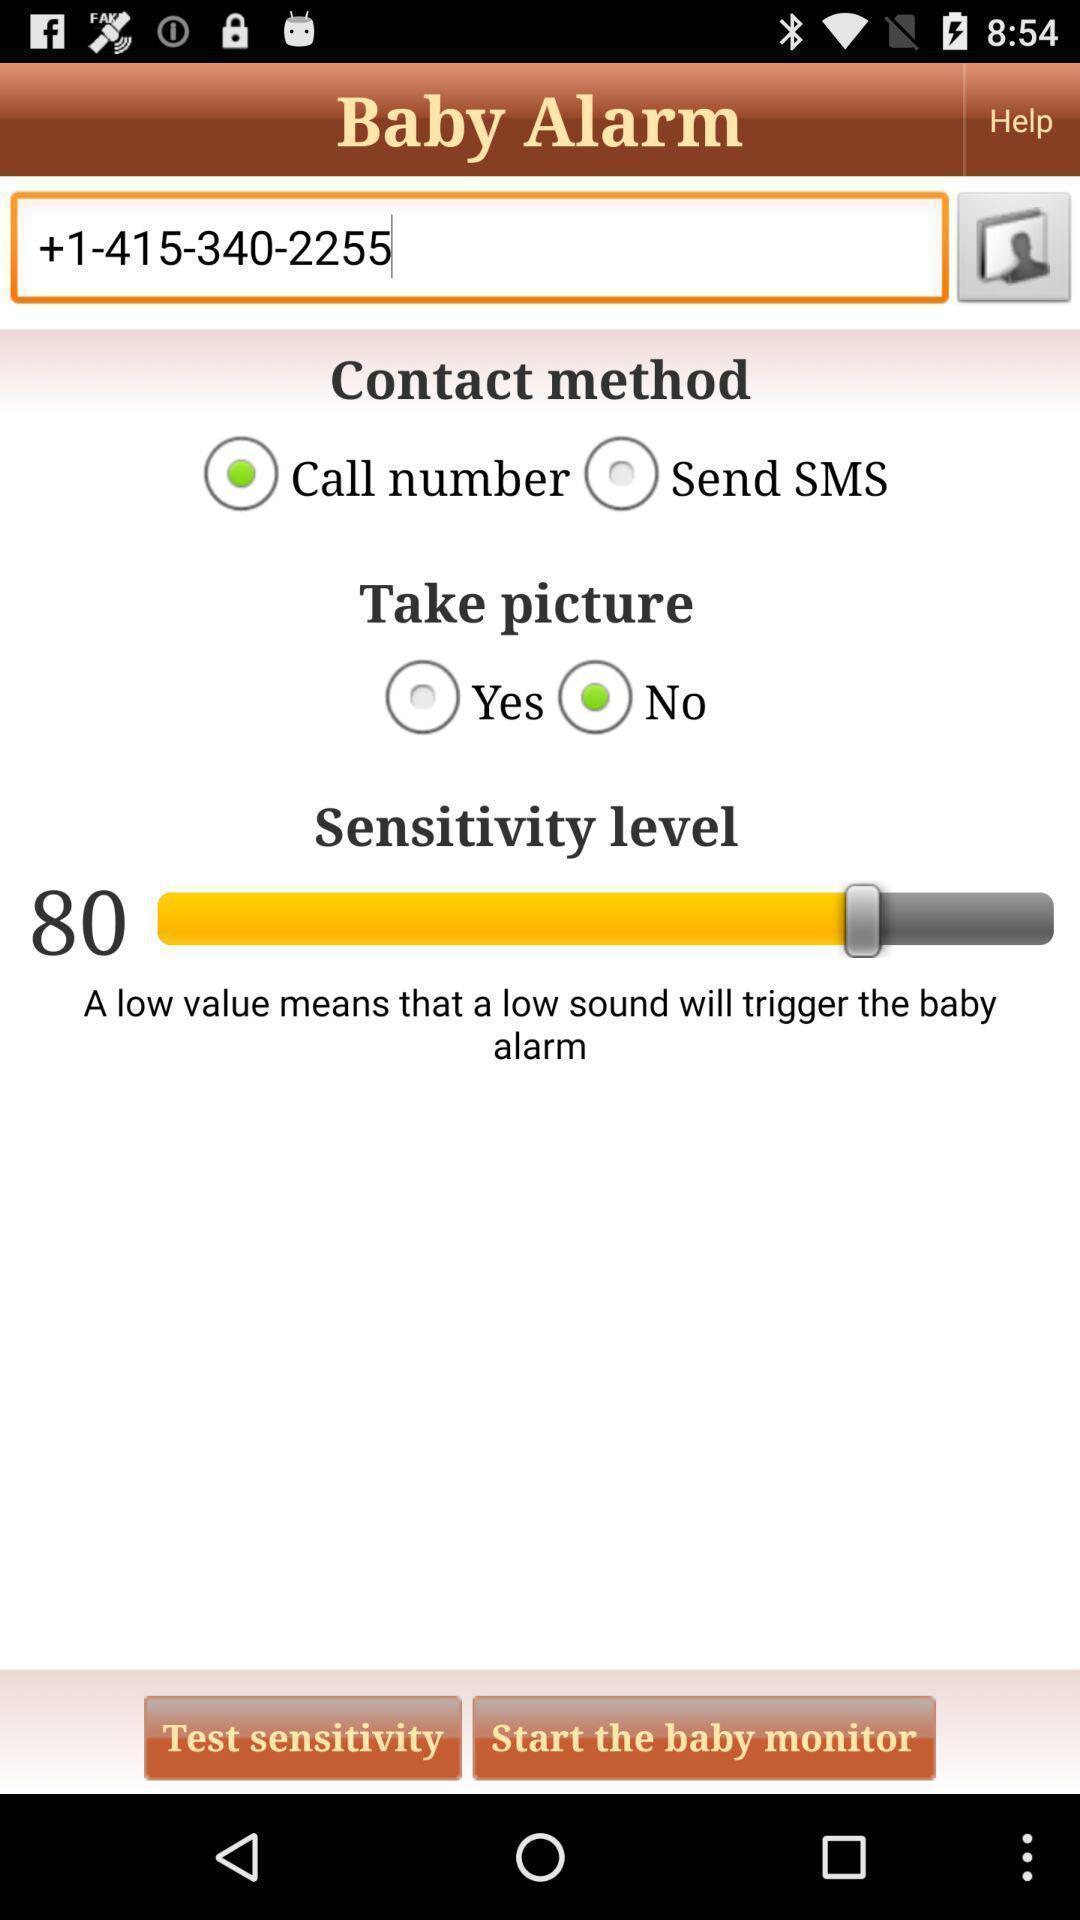Provide a description of this screenshot. Screen displaying multiple options in a remainder application. 